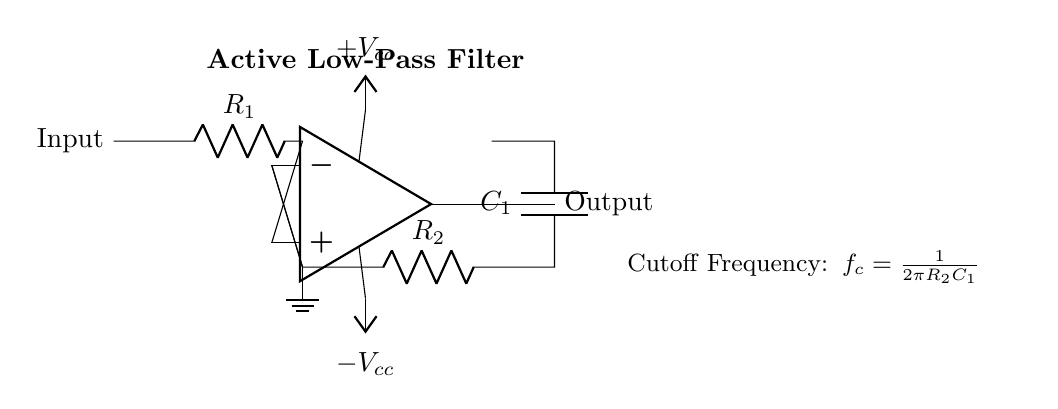What type of filter is represented in this circuit? The circuit represents an active low-pass filter as indicated by the label in the diagram. An active low-pass filter allows low-frequency signals to pass through while attenuating high-frequency signals.
Answer: active low-pass filter What are the values of the resistor and capacitor in the feedback network? The feedback network consists of a resistor labeled as R2 and a capacitor labeled as C1. The specific numerical values are not provided in the diagram, but they are essential for determining the cutoff frequency.
Answer: R2, C1 What is the cutoff frequency formula given in the circuit? The cutoff frequency formula provided in the circuit is f_c = 1/(2πR2C1). This equation defines the point at which the output signal is reduced by approximately 3 dB in relation to the input signal, based on the values of the resistor and capacitor in the feedback loop.
Answer: 1/(2πR2C1) How many power supply connections are shown in this circuit? The circuit shows two power supply connections: one for positive voltage labeled +V_cc and one for negative voltage labeled -V_cc. This dual supply is characteristic for op-amps to allow for a full range of output voltages.
Answer: two Which component is responsible for feedback in this circuit? The feedback in this circuit is provided through the resistor R2 and the capacitor C1, which form a feedback network connected to the inverting input of the operational amplifier. These components influence the behavior and characteristics of the filter.
Answer: R2 and C1 What is the role of the operational amplifier in this circuit? The operational amplifier is responsible for amplifying the input voltage and controlling the overall gain of the filter circuit. It works in conjunction with the resistors and capacitor to shape the frequency response of the active low-pass filter.
Answer: amplification Where is the ground reference located in the circuit? The ground reference is indicated at the bottom of the circuit connected to the inverting input of the op-amp, creating a common return path for the current in the circuit. This is crucial for establishing a stable reference point for the operation of the circuit.
Answer: at the inverting input of the op-amp 